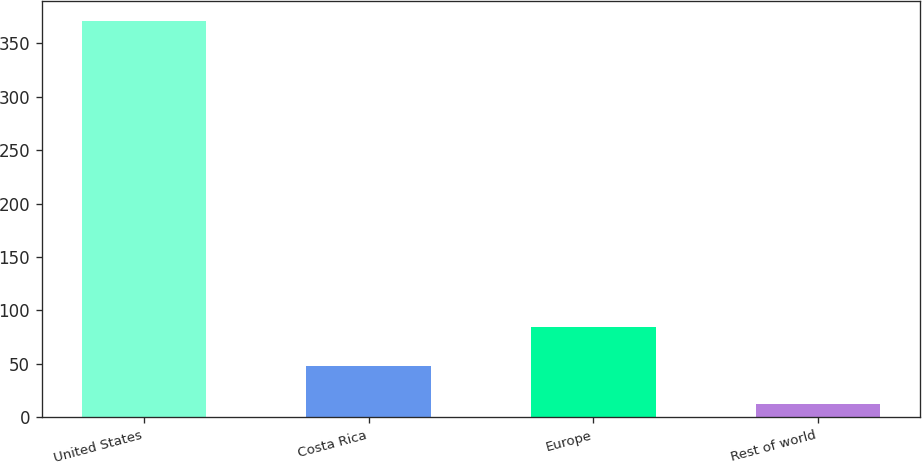Convert chart to OTSL. <chart><loc_0><loc_0><loc_500><loc_500><bar_chart><fcel>United States<fcel>Costa Rica<fcel>Europe<fcel>Rest of world<nl><fcel>370.7<fcel>48.05<fcel>83.9<fcel>12.2<nl></chart> 